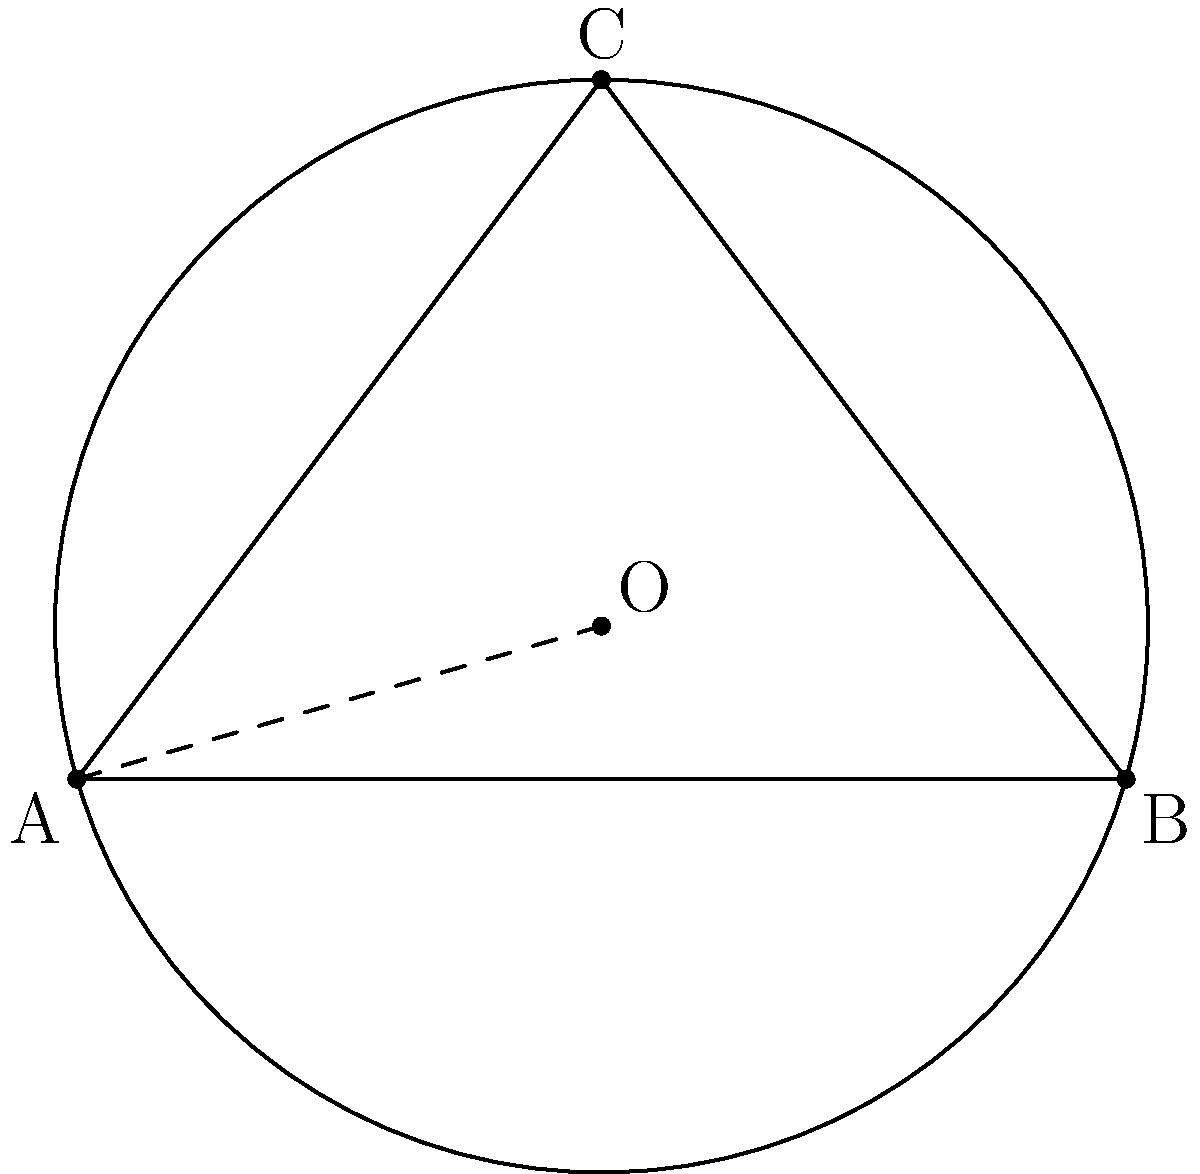In the classic film "2001: A Space Odyssey," the mysterious monolith appears at three distinct locations, forming a perfect circle in space. If we represent these locations as points A(0,0), B(6,0), and C(3,4) on a coordinate plane, determine the center and radius of this cosmic circle. How might this geometric arrangement reflect the film's themes of evolution and cosmic significance? To find the center and radius of the circle, we'll follow these steps:

1) The center of the circle is the point equidistant from A, B, and C. This point is called the circumcenter.

2) To find the circumcenter, we need to calculate the perpendicular bisectors of any two sides of the triangle ABC.

3) For side AB:
   Midpoint: $(\frac{0+6}{2}, \frac{0+0}{2}) = (3,0)$
   Slope of AB: $m_{AB} = \frac{0-0}{6-0} = 0$
   Perpendicular slope: $m_{\perp AB} = -\frac{1}{0} = undefined$ (vertical line)
   Equation of perpendicular bisector: $x = 3$

4) For side BC:
   Midpoint: $(\frac{6+3}{2}, \frac{0+4}{2}) = (4.5,2)$
   Slope of BC: $m_{BC} = \frac{4-0}{3-6} = -\frac{4}{3}$
   Perpendicular slope: $m_{\perp BC} = \frac{3}{4}$
   Equation of perpendicular bisector: $y - 2 = \frac{3}{4}(x - 4.5)$

5) The intersection of these two lines gives the center:
   $x = 3$
   $y - 2 = \frac{3}{4}(3 - 4.5) = -\frac{9}{8}$
   $y = 2 - \frac{9}{8} = \frac{7}{8}$

   So, the center is at $(3, \frac{7}{8})$

6) To find the radius, we can calculate the distance from the center to any of the three points:

   $r = \sqrt{(3-0)^2 + (\frac{7}{8}-0)^2} = \sqrt{9 + \frac{49}{64}} = \sqrt{\frac{625}{64}} = \frac{25}{8} = 3.125$

This circular arrangement in the film could symbolize the cyclical nature of evolution or the interconnectedness of space and time, key themes in "2001: A Space Odyssey."
Answer: Center: $(3, \frac{7}{8})$, Radius: $\frac{25}{8}$ 